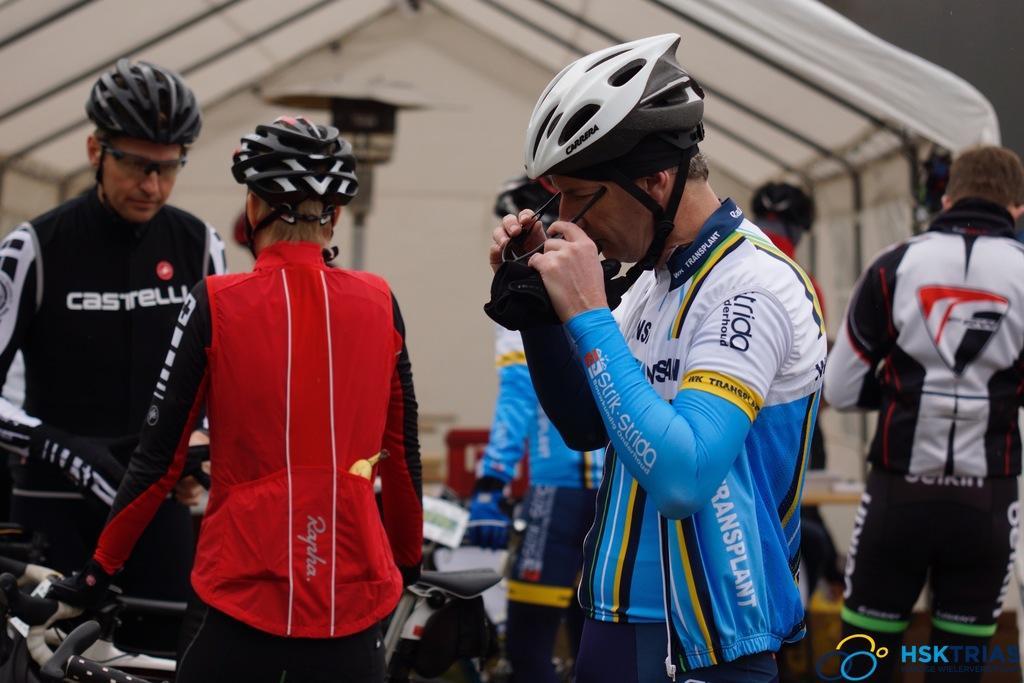How would you summarize this image in a sentence or two? In the center of the image we can see persons standing at the bicycles. In the background we can see tent and person. 